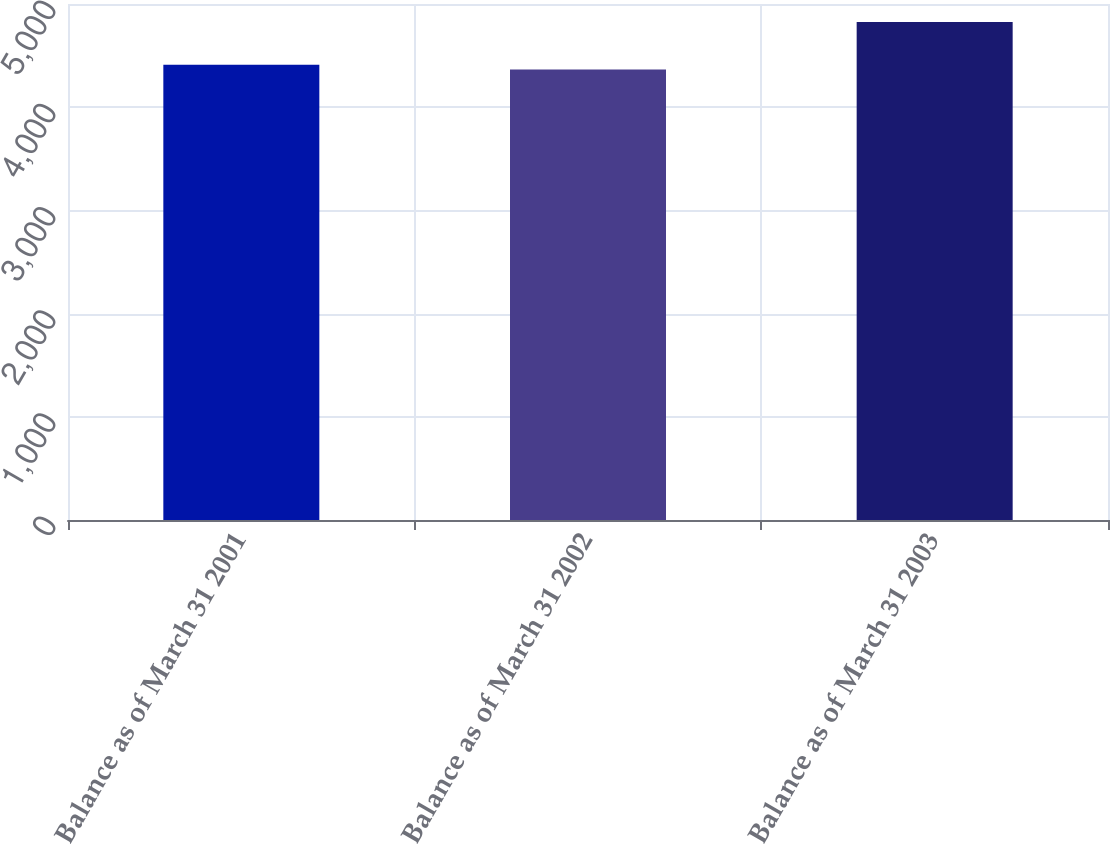<chart> <loc_0><loc_0><loc_500><loc_500><bar_chart><fcel>Balance as of March 31 2001<fcel>Balance as of March 31 2002<fcel>Balance as of March 31 2003<nl><fcel>4411.9<fcel>4366<fcel>4825<nl></chart> 